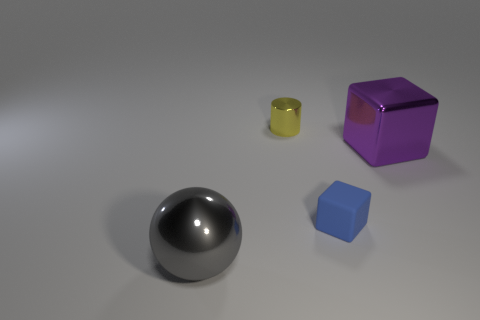Add 3 gray objects. How many objects exist? 7 Subtract all cylinders. How many objects are left? 3 Add 2 yellow blocks. How many yellow blocks exist? 2 Subtract 1 yellow cylinders. How many objects are left? 3 Subtract all tiny cubes. Subtract all yellow matte spheres. How many objects are left? 3 Add 1 matte cubes. How many matte cubes are left? 2 